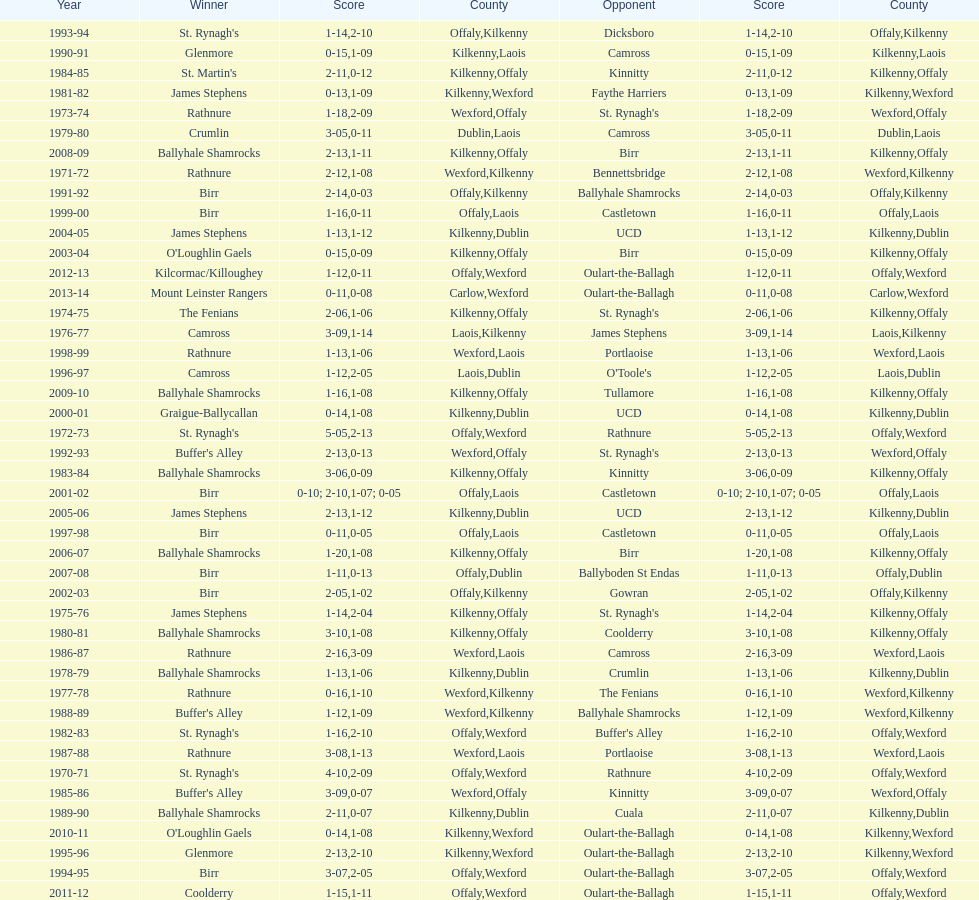What was the last season the leinster senior club hurling championships was won by a score differential of less than 11? 2007-08. 